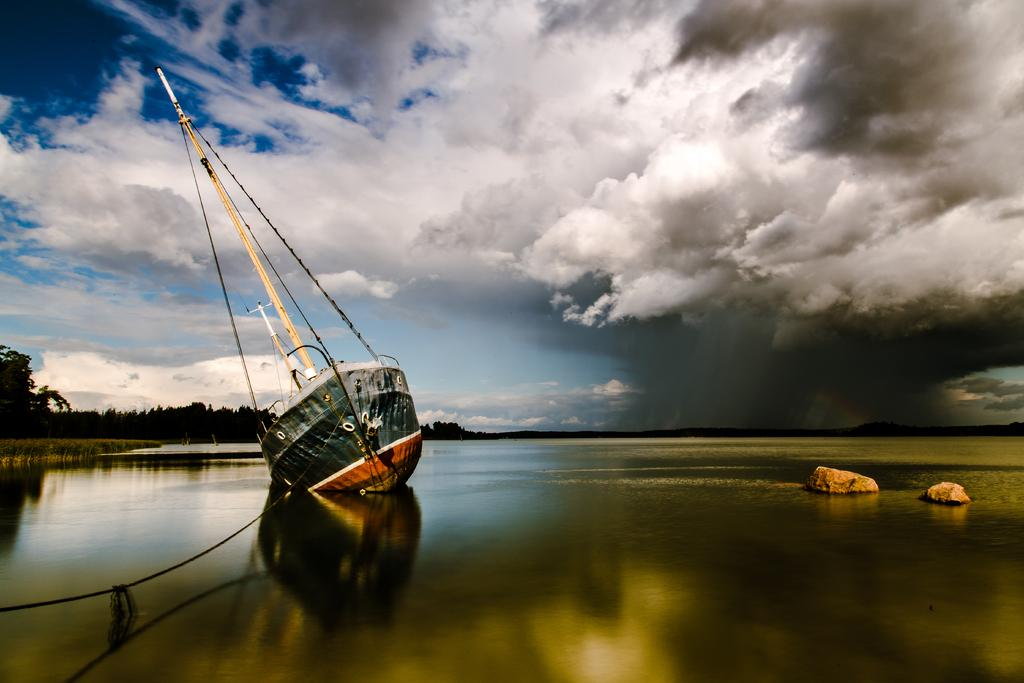What body of water is present at the bottom of the image? There is a river at the bottom of the image. What is in the river? There is a boat in the river. Are there any other objects in the river besides the boat? Yes, there are two rocks in the river. What can be seen in the background of the image? There are trees in the background of the image. What is visible at the top of the image? The sky is visible at the top of the image. What type of watch is the slave wearing in the image? There is no watch or slave present in the image. The image features a river, a boat, rocks, trees, and the sky. 